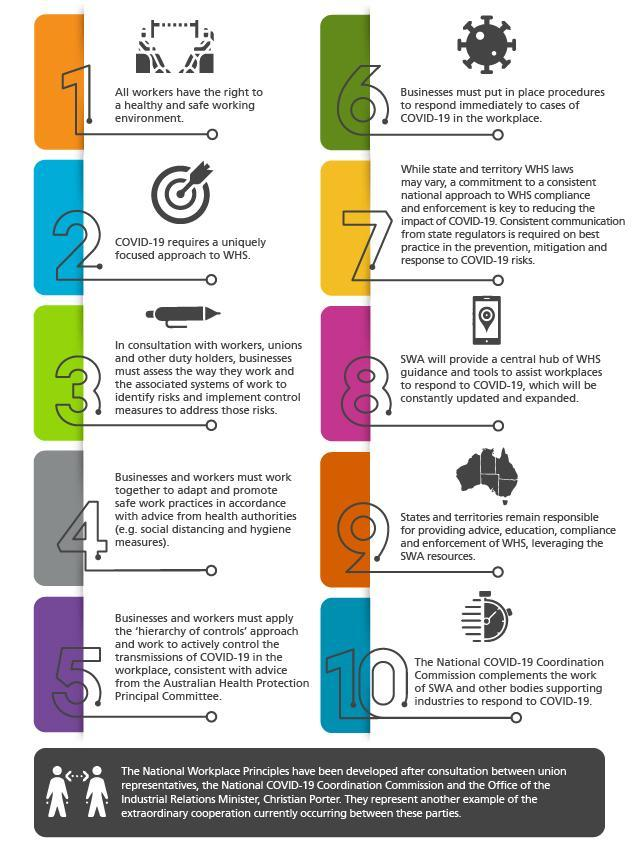Who is responsible to provide advice, education, compliance and enforcement of WHS?
Answer the question with a short phrase. States and territories As per point 4, what safe practices can be adapted at work place? social distancing and hygiene measures Who will provide guidance and tools to assist workplaces to respond to COVID-19? SWA About what should state regulators provide consistent communication? best practice in the prevention, mitigation and response to COVID-19 risks 